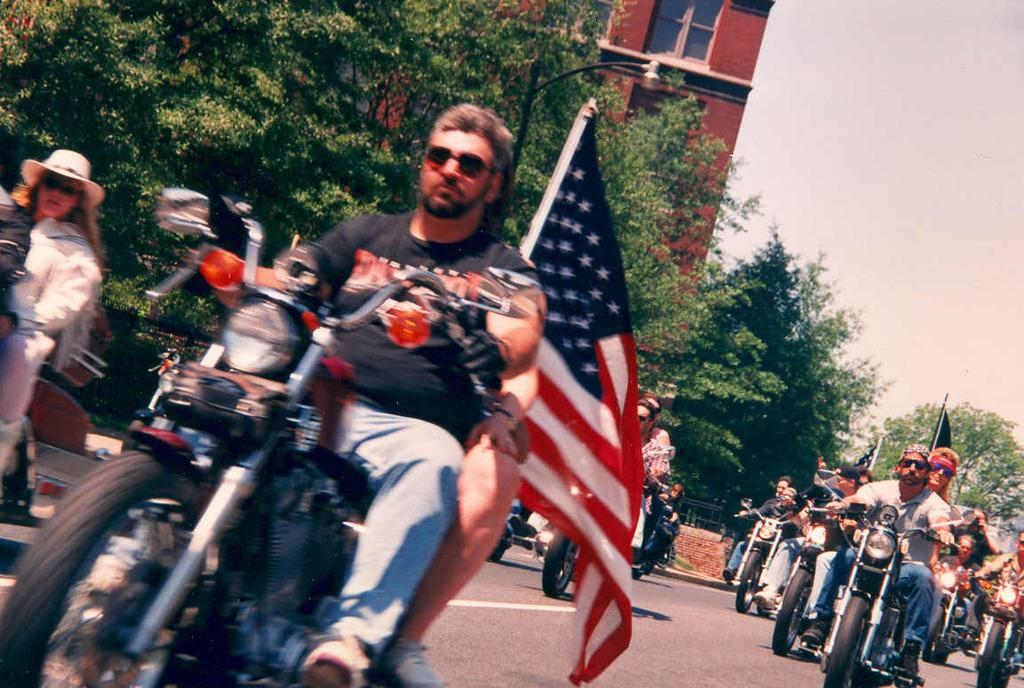What type of vegetation can be seen in the image? There are trees in the image. What type of structure is present in the image? There is a building in the image. What is visible in the background of the image? The sky is visible in the image. What are the people in the image doing? The people are sitting on a motorcycle in the image. Where is the head of the frog in the image? There is no frog present in the image, so its head cannot be located. What type of hose is connected to the building in the image? There is no hose connected to the building in the image. 